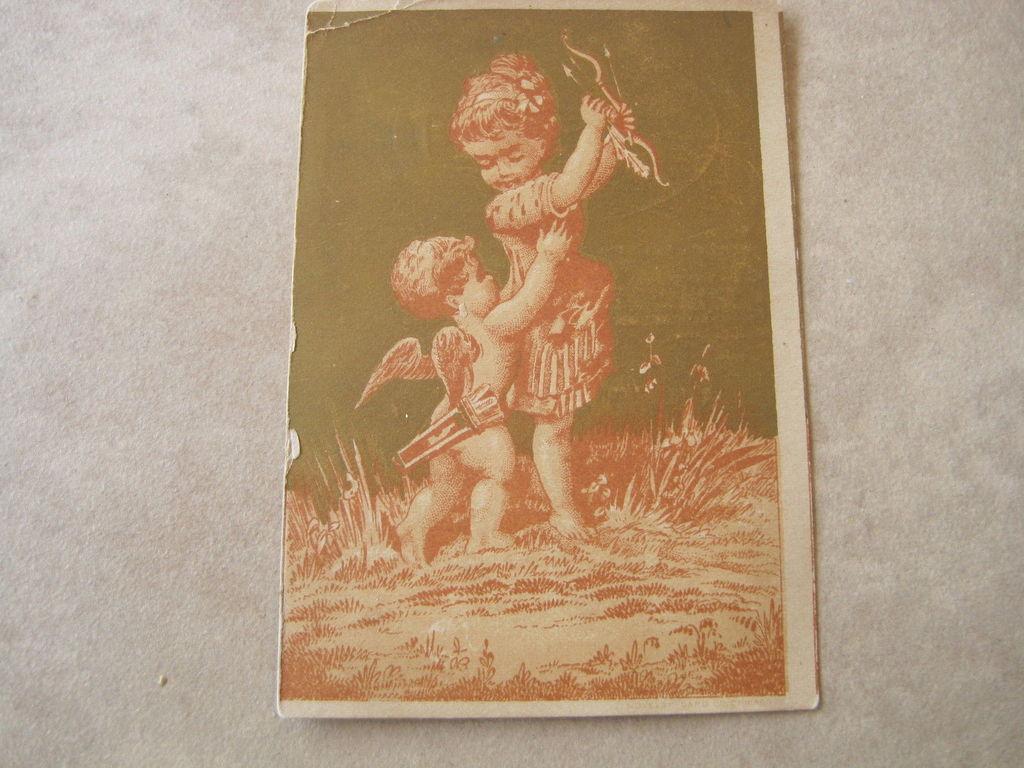Please provide a concise description of this image. In this image we can see one frame attached to the wall, in this frame there are two children holding some objects, some grass on the surface and one small boy having two wings. 